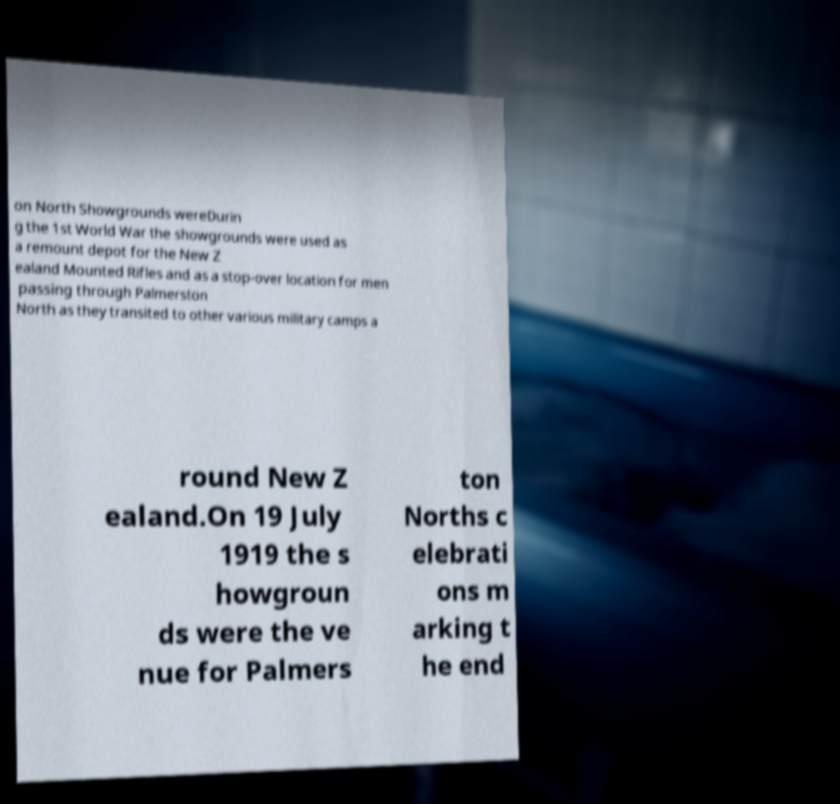I need the written content from this picture converted into text. Can you do that? on North Showgrounds wereDurin g the 1st World War the showgrounds were used as a remount depot for the New Z ealand Mounted Rifles and as a stop-over location for men passing through Palmerston North as they transited to other various military camps a round New Z ealand.On 19 July 1919 the s howgroun ds were the ve nue for Palmers ton Norths c elebrati ons m arking t he end 